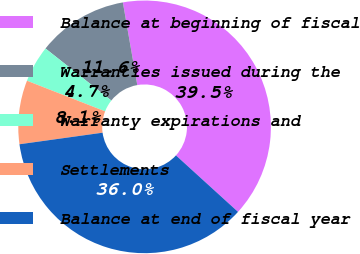<chart> <loc_0><loc_0><loc_500><loc_500><pie_chart><fcel>Balance at beginning of fiscal<fcel>Warranties issued during the<fcel>Warranty expirations and<fcel>Settlements<fcel>Balance at end of fiscal year<nl><fcel>39.5%<fcel>11.6%<fcel>4.7%<fcel>8.15%<fcel>36.05%<nl></chart> 